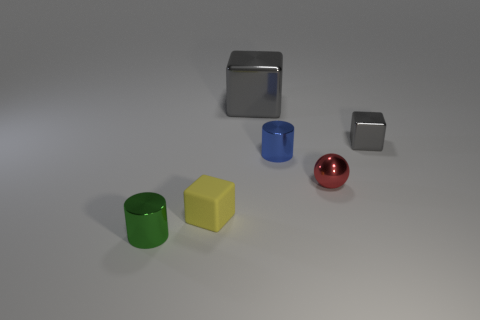Add 1 small cyan cubes. How many objects exist? 7 Subtract all cylinders. How many objects are left? 4 Subtract 0 green cubes. How many objects are left? 6 Subtract all green cubes. Subtract all tiny yellow blocks. How many objects are left? 5 Add 5 small shiny blocks. How many small shiny blocks are left? 6 Add 1 green cylinders. How many green cylinders exist? 2 